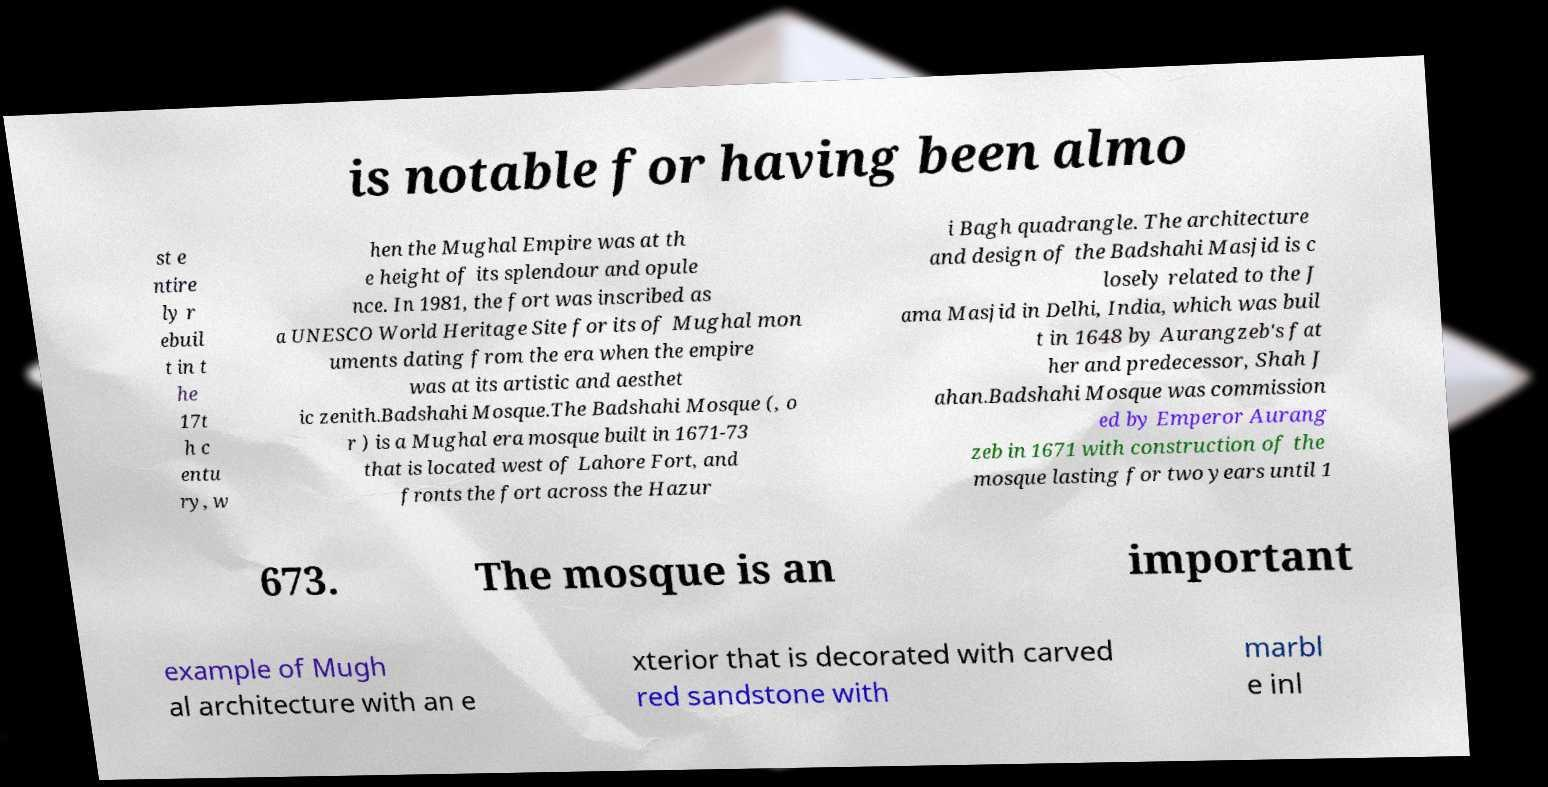Could you extract and type out the text from this image? is notable for having been almo st e ntire ly r ebuil t in t he 17t h c entu ry, w hen the Mughal Empire was at th e height of its splendour and opule nce. In 1981, the fort was inscribed as a UNESCO World Heritage Site for its of Mughal mon uments dating from the era when the empire was at its artistic and aesthet ic zenith.Badshahi Mosque.The Badshahi Mosque (, o r ) is a Mughal era mosque built in 1671-73 that is located west of Lahore Fort, and fronts the fort across the Hazur i Bagh quadrangle. The architecture and design of the Badshahi Masjid is c losely related to the J ama Masjid in Delhi, India, which was buil t in 1648 by Aurangzeb's fat her and predecessor, Shah J ahan.Badshahi Mosque was commission ed by Emperor Aurang zeb in 1671 with construction of the mosque lasting for two years until 1 673. The mosque is an important example of Mugh al architecture with an e xterior that is decorated with carved red sandstone with marbl e inl 